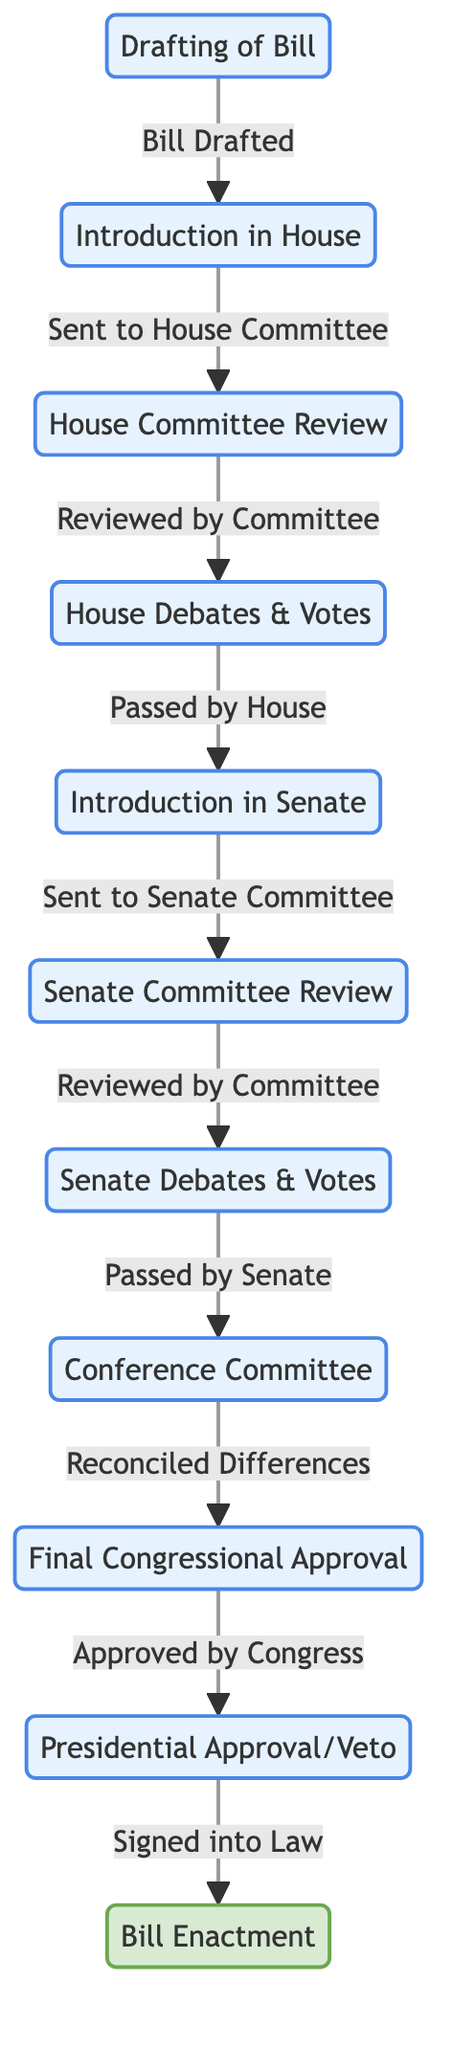What is the first step in the legislative process? The first step is "Drafting of Bill," which is represented as node 1 in the diagram.
Answer: Drafting of Bill How many nodes are there in total? The diagram contains 11 nodes, representing different steps in the legislative process.
Answer: 11 What happens after "House Debates & Votes"? After "House Debates & Votes," the next step is "Introduction in Senate," which is shown as node 5.
Answer: Introduction in Senate What connects "Senate Committee Review" and "Senate Debates & Votes"? "Senate Committee Review" connects to "Senate Debates & Votes" through the edge labeled "Reviewed by Committee."
Answer: Reviewed by Committee What is the final outcome of the legislative process? The final outcome is "Bill Enactment," which is represented as node 11 in the diagram.
Answer: Bill Enactment What are the two major phases after a bill is drafted? The two major phases after drafting are "Introduction in House" and "Introduction in Senate," representing the transition from the House to Senate.
Answer: Introduction in House, Introduction in Senate How many edges are in the diagram? There are 10 edges, indicating the connections and flow between the nodes in the legislative process.
Answer: 10 What occurs if a bill is passed by the Senate? If a bill is passed by the Senate, it moves to the "Conference Committee," which signifies the reconciliation of differences.
Answer: Conference Committee What step follows after "Final Congressional Approval"? The step that follows is "Presidential Approval/Veto," indicating that the bill is now awaiting the president's action.
Answer: Presidential Approval/Veto 